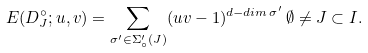Convert formula to latex. <formula><loc_0><loc_0><loc_500><loc_500>E ( D ^ { \circ } _ { J } ; u , v ) = \sum _ { \sigma ^ { \prime } \in \Sigma _ { \circ } ^ { \prime } ( J ) } ( u v - 1 ) ^ { d - d i m \, \sigma ^ { \prime } } \, \emptyset \neq J \subset I .</formula> 